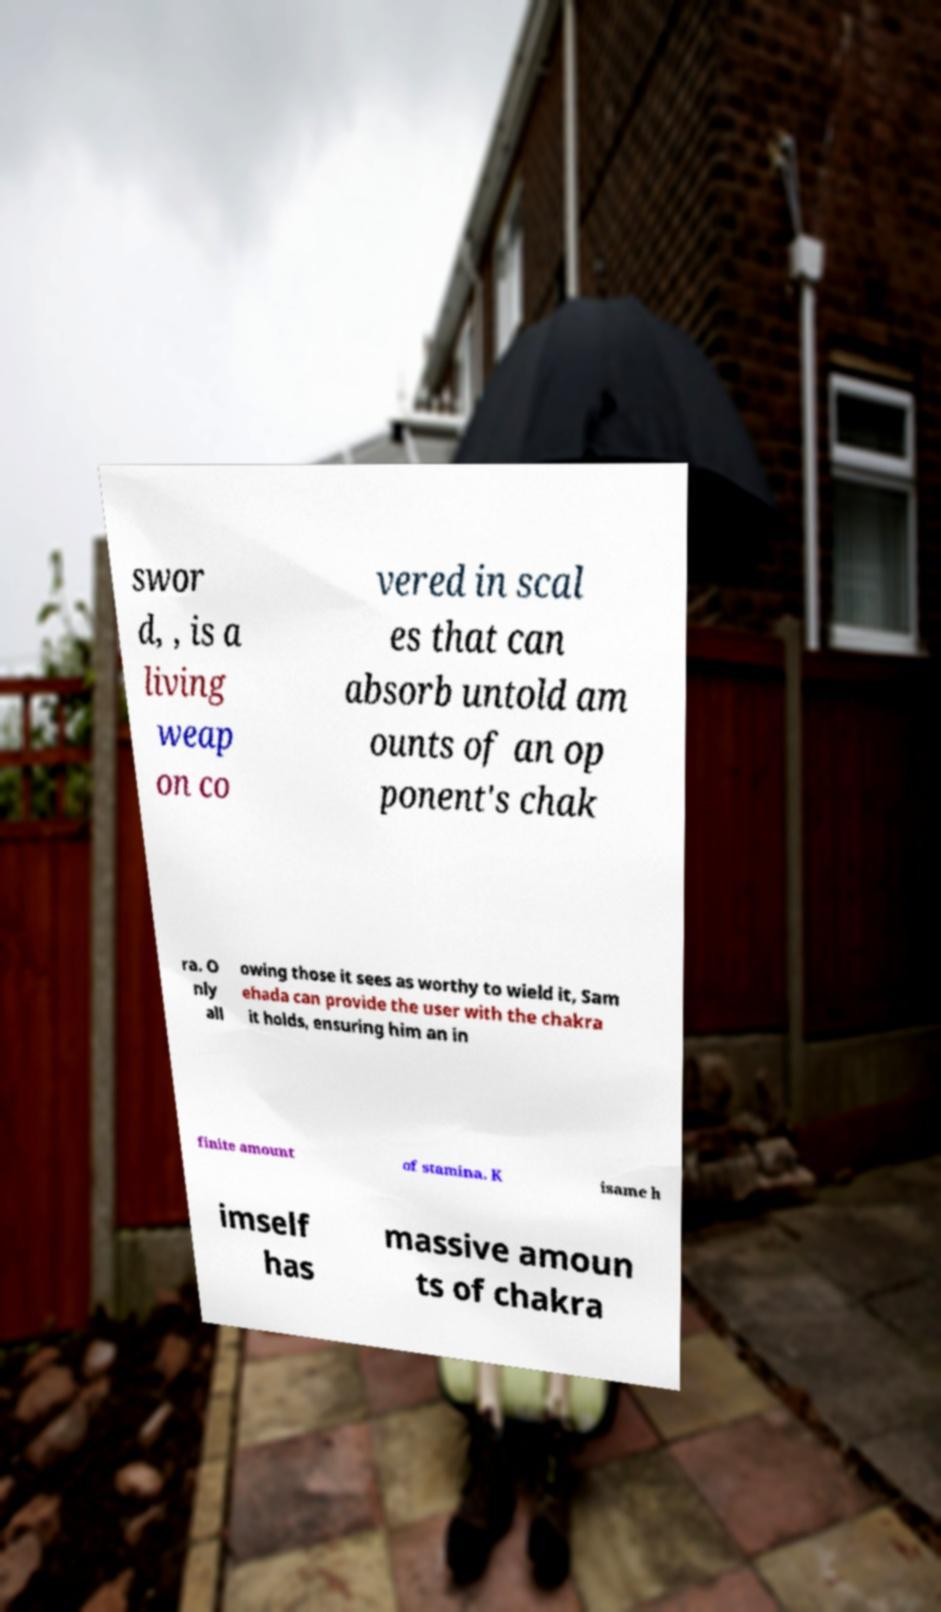For documentation purposes, I need the text within this image transcribed. Could you provide that? swor d, , is a living weap on co vered in scal es that can absorb untold am ounts of an op ponent's chak ra. O nly all owing those it sees as worthy to wield it, Sam ehada can provide the user with the chakra it holds, ensuring him an in finite amount of stamina. K isame h imself has massive amoun ts of chakra 